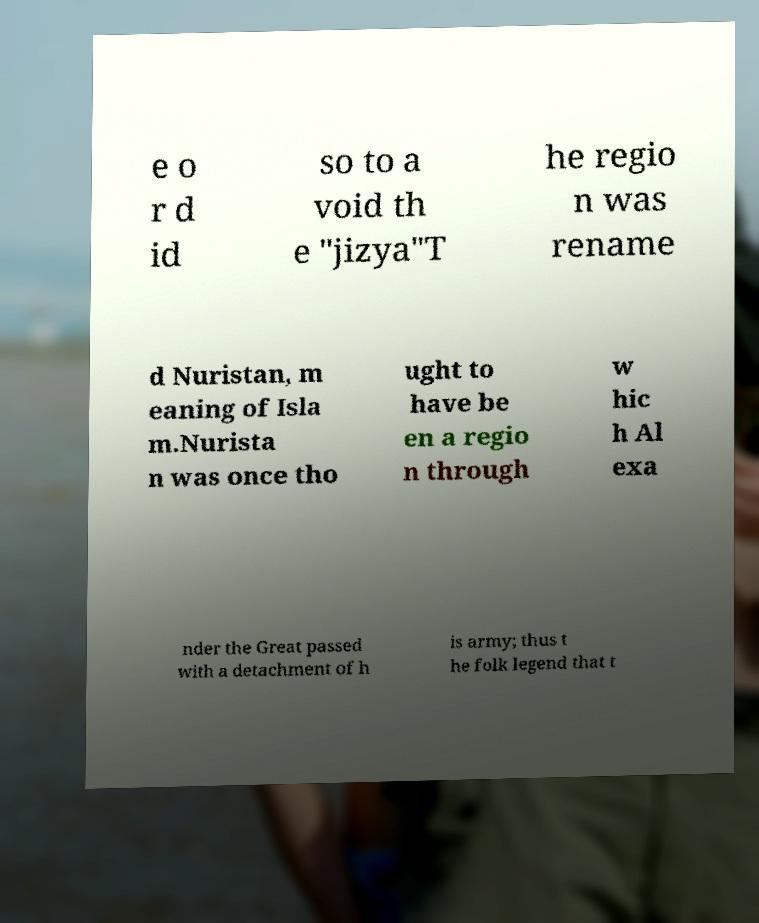What messages or text are displayed in this image? I need them in a readable, typed format. e o r d id so to a void th e "jizya"T he regio n was rename d Nuristan, m eaning of Isla m.Nurista n was once tho ught to have be en a regio n through w hic h Al exa nder the Great passed with a detachment of h is army; thus t he folk legend that t 